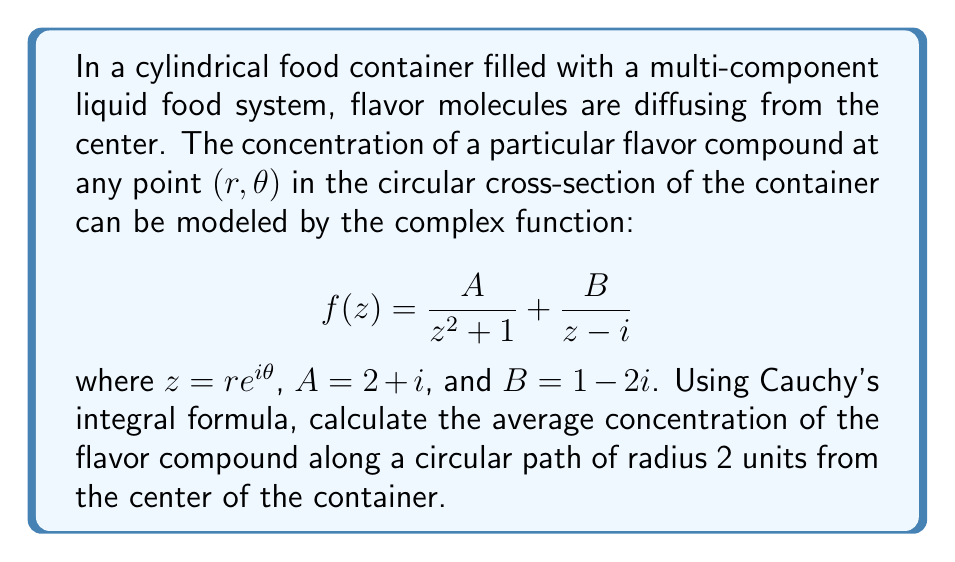Show me your answer to this math problem. To solve this problem, we'll use Cauchy's integral formula and follow these steps:

1) Cauchy's integral formula states that for an analytic function $f(z)$ inside and on a simple closed contour $C$, and for any point $a$ inside $C$:

   $$f(a) = \frac{1}{2\pi i} \oint_C \frac{f(z)}{z - a} dz$$

2) The average value of $f(z)$ on a circle of radius $R$ centered at the origin is given by:

   $$\frac{1}{2\pi R} \int_0^{2\pi} f(Re^{i\theta}) Rd\theta = \frac{1}{2\pi i} \oint_{|z|=R} \frac{f(z)}{z} dz$$

3) In our case, $R = 2$ and we need to calculate:

   $$\frac{1}{2\pi i} \oint_{|z|=2} \frac{1}{z}\left(\frac{A}{z^2 + 1} + \frac{B}{z - i}\right) dz$$

4) This integral can be split into two parts:

   $$\frac{1}{2\pi i} \oint_{|z|=2} \frac{A}{z(z^2 + 1)} dz + \frac{1}{2\pi i} \oint_{|z|=2} \frac{B}{z(z - i)} dz$$

5) For the first integral, the singularities inside $|z|=2$ are at $z = i$ and $z = 0$. We can use the residue theorem:

   $$\text{Res}(f, 0) = A$$
   $$\text{Res}(f, i) = \frac{A}{2i}$$

6) For the second integral, the only singularity inside $|z|=2$ is at $z = i$:

   $$\text{Res}(f, i) = B$$

7) Adding these residues:

   $$A + \frac{A}{2i} + B = (2+i) + \frac{2+i}{2i} + (1-2i)$$

8) Simplifying:

   $$(2+i) + \frac{2i-1}{2} + (1-2i) = 3 - \frac{1}{2} - i = \frac{5}{2} - i$$
Answer: The average concentration of the flavor compound along a circular path of radius 2 units from the center of the container is $\frac{5}{2} - i$. 